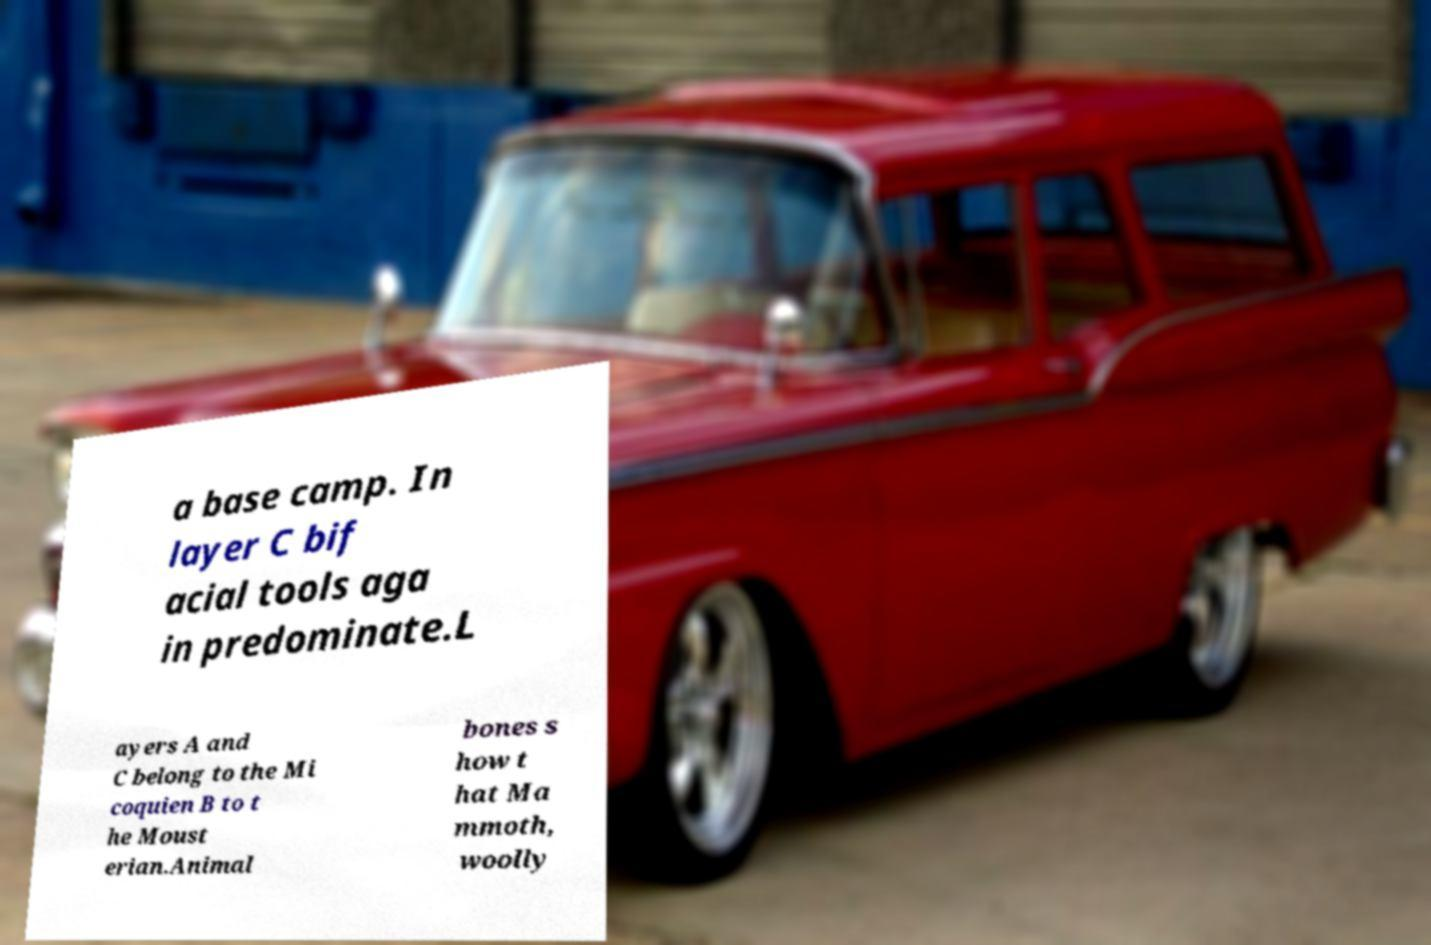I need the written content from this picture converted into text. Can you do that? a base camp. In layer C bif acial tools aga in predominate.L ayers A and C belong to the Mi coquien B to t he Moust erian.Animal bones s how t hat Ma mmoth, woolly 